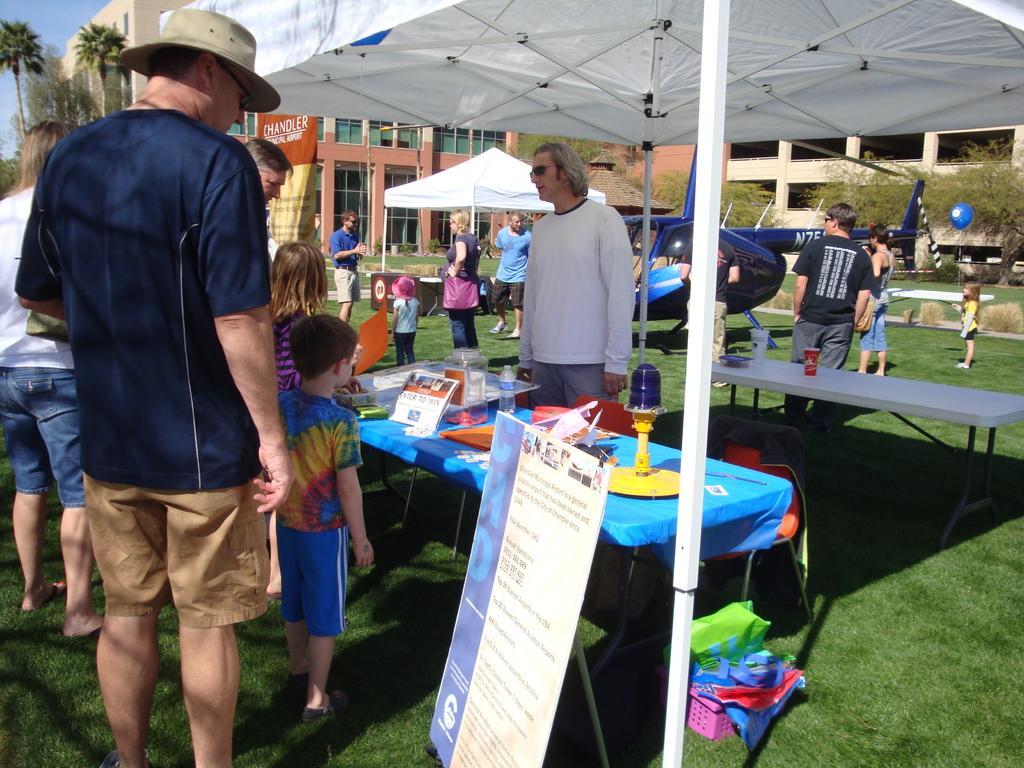Could you give a brief overview of what you see in this image? On the left side of the image we can see a man standing on the grass. This is the helicopter. There is a tent under which there is a table. In the background we can see trees and buildings. 